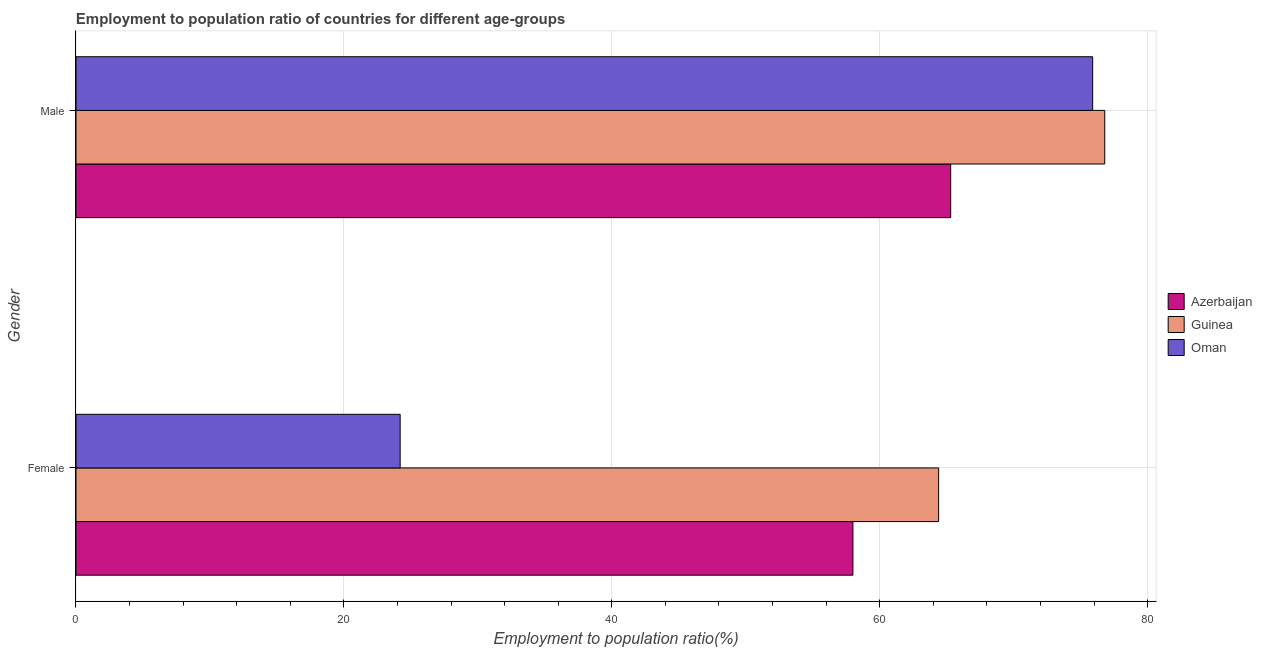How many groups of bars are there?
Offer a terse response. 2. Are the number of bars per tick equal to the number of legend labels?
Your answer should be compact. Yes. How many bars are there on the 1st tick from the top?
Ensure brevity in your answer.  3. How many bars are there on the 2nd tick from the bottom?
Provide a succinct answer. 3. What is the employment to population ratio(female) in Azerbaijan?
Ensure brevity in your answer.  58. Across all countries, what is the maximum employment to population ratio(female)?
Your response must be concise. 64.4. Across all countries, what is the minimum employment to population ratio(male)?
Provide a succinct answer. 65.3. In which country was the employment to population ratio(male) maximum?
Give a very brief answer. Guinea. In which country was the employment to population ratio(male) minimum?
Offer a terse response. Azerbaijan. What is the total employment to population ratio(male) in the graph?
Provide a succinct answer. 218. What is the difference between the employment to population ratio(male) in Guinea and that in Azerbaijan?
Provide a succinct answer. 11.5. What is the difference between the employment to population ratio(female) in Azerbaijan and the employment to population ratio(male) in Oman?
Provide a succinct answer. -17.9. What is the average employment to population ratio(female) per country?
Your response must be concise. 48.87. What is the difference between the employment to population ratio(male) and employment to population ratio(female) in Oman?
Your answer should be very brief. 51.7. In how many countries, is the employment to population ratio(male) greater than 4 %?
Provide a succinct answer. 3. What is the ratio of the employment to population ratio(female) in Oman to that in Azerbaijan?
Provide a succinct answer. 0.42. Is the employment to population ratio(male) in Oman less than that in Azerbaijan?
Provide a succinct answer. No. In how many countries, is the employment to population ratio(male) greater than the average employment to population ratio(male) taken over all countries?
Make the answer very short. 2. What does the 3rd bar from the top in Female represents?
Your response must be concise. Azerbaijan. What does the 3rd bar from the bottom in Female represents?
Provide a short and direct response. Oman. How many bars are there?
Your answer should be compact. 6. Are all the bars in the graph horizontal?
Your response must be concise. Yes. How many countries are there in the graph?
Your answer should be compact. 3. What is the difference between two consecutive major ticks on the X-axis?
Offer a very short reply. 20. Are the values on the major ticks of X-axis written in scientific E-notation?
Keep it short and to the point. No. How many legend labels are there?
Provide a short and direct response. 3. What is the title of the graph?
Provide a short and direct response. Employment to population ratio of countries for different age-groups. What is the Employment to population ratio(%) of Guinea in Female?
Your response must be concise. 64.4. What is the Employment to population ratio(%) of Oman in Female?
Ensure brevity in your answer.  24.2. What is the Employment to population ratio(%) in Azerbaijan in Male?
Offer a terse response. 65.3. What is the Employment to population ratio(%) in Guinea in Male?
Your answer should be very brief. 76.8. What is the Employment to population ratio(%) in Oman in Male?
Offer a very short reply. 75.9. Across all Gender, what is the maximum Employment to population ratio(%) of Azerbaijan?
Offer a terse response. 65.3. Across all Gender, what is the maximum Employment to population ratio(%) in Guinea?
Your answer should be compact. 76.8. Across all Gender, what is the maximum Employment to population ratio(%) of Oman?
Give a very brief answer. 75.9. Across all Gender, what is the minimum Employment to population ratio(%) of Azerbaijan?
Your answer should be very brief. 58. Across all Gender, what is the minimum Employment to population ratio(%) in Guinea?
Offer a very short reply. 64.4. Across all Gender, what is the minimum Employment to population ratio(%) in Oman?
Provide a succinct answer. 24.2. What is the total Employment to population ratio(%) of Azerbaijan in the graph?
Give a very brief answer. 123.3. What is the total Employment to population ratio(%) in Guinea in the graph?
Ensure brevity in your answer.  141.2. What is the total Employment to population ratio(%) of Oman in the graph?
Offer a terse response. 100.1. What is the difference between the Employment to population ratio(%) of Oman in Female and that in Male?
Offer a very short reply. -51.7. What is the difference between the Employment to population ratio(%) of Azerbaijan in Female and the Employment to population ratio(%) of Guinea in Male?
Offer a terse response. -18.8. What is the difference between the Employment to population ratio(%) in Azerbaijan in Female and the Employment to population ratio(%) in Oman in Male?
Your answer should be very brief. -17.9. What is the difference between the Employment to population ratio(%) in Guinea in Female and the Employment to population ratio(%) in Oman in Male?
Provide a short and direct response. -11.5. What is the average Employment to population ratio(%) in Azerbaijan per Gender?
Give a very brief answer. 61.65. What is the average Employment to population ratio(%) of Guinea per Gender?
Make the answer very short. 70.6. What is the average Employment to population ratio(%) in Oman per Gender?
Provide a succinct answer. 50.05. What is the difference between the Employment to population ratio(%) of Azerbaijan and Employment to population ratio(%) of Oman in Female?
Your response must be concise. 33.8. What is the difference between the Employment to population ratio(%) in Guinea and Employment to population ratio(%) in Oman in Female?
Give a very brief answer. 40.2. What is the difference between the Employment to population ratio(%) in Guinea and Employment to population ratio(%) in Oman in Male?
Offer a terse response. 0.9. What is the ratio of the Employment to population ratio(%) in Azerbaijan in Female to that in Male?
Your answer should be compact. 0.89. What is the ratio of the Employment to population ratio(%) in Guinea in Female to that in Male?
Keep it short and to the point. 0.84. What is the ratio of the Employment to population ratio(%) in Oman in Female to that in Male?
Your answer should be very brief. 0.32. What is the difference between the highest and the second highest Employment to population ratio(%) in Guinea?
Ensure brevity in your answer.  12.4. What is the difference between the highest and the second highest Employment to population ratio(%) in Oman?
Offer a terse response. 51.7. What is the difference between the highest and the lowest Employment to population ratio(%) of Azerbaijan?
Your answer should be compact. 7.3. What is the difference between the highest and the lowest Employment to population ratio(%) of Guinea?
Your response must be concise. 12.4. What is the difference between the highest and the lowest Employment to population ratio(%) of Oman?
Keep it short and to the point. 51.7. 